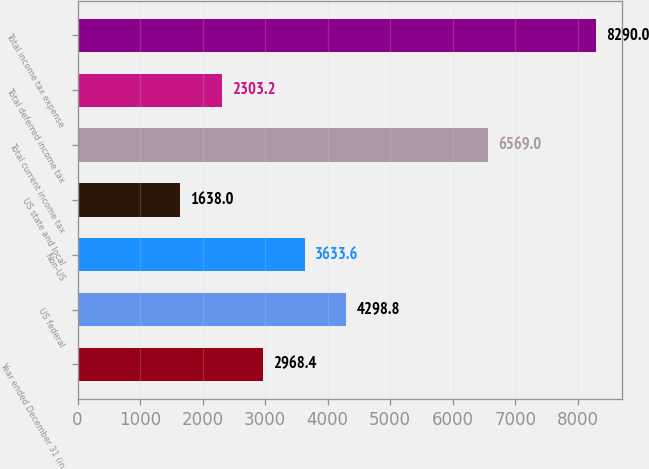Convert chart. <chart><loc_0><loc_0><loc_500><loc_500><bar_chart><fcel>Year ended December 31 (in<fcel>US federal<fcel>Non-US<fcel>US state and local<fcel>Total current income tax<fcel>Total deferred income tax<fcel>Total income tax expense<nl><fcel>2968.4<fcel>4298.8<fcel>3633.6<fcel>1638<fcel>6569<fcel>2303.2<fcel>8290<nl></chart> 